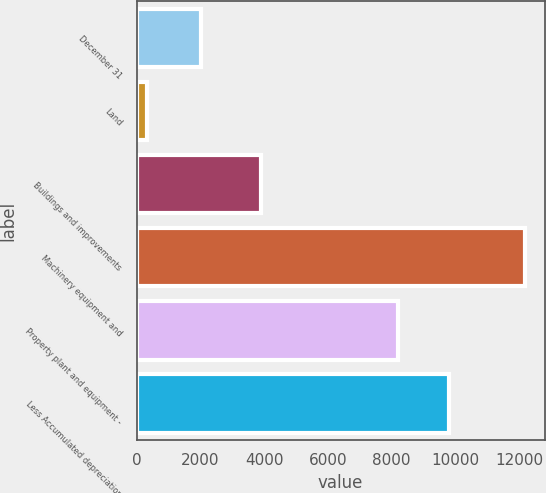Convert chart to OTSL. <chart><loc_0><loc_0><loc_500><loc_500><bar_chart><fcel>December 31<fcel>Land<fcel>Buildings and improvements<fcel>Machinery equipment and<fcel>Property plant and equipment -<fcel>Less Accumulated depreciation<nl><fcel>2017<fcel>334<fcel>3917<fcel>12198<fcel>8203<fcel>9814.5<nl></chart> 